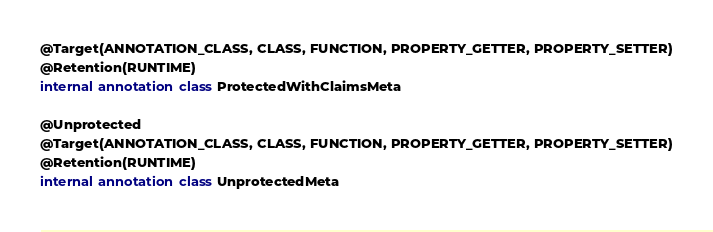Convert code to text. <code><loc_0><loc_0><loc_500><loc_500><_Kotlin_>@Target(ANNOTATION_CLASS, CLASS, FUNCTION, PROPERTY_GETTER, PROPERTY_SETTER)
@Retention(RUNTIME)
internal annotation class ProtectedWithClaimsMeta

@Unprotected
@Target(ANNOTATION_CLASS, CLASS, FUNCTION, PROPERTY_GETTER, PROPERTY_SETTER)
@Retention(RUNTIME)
internal annotation class UnprotectedMeta</code> 